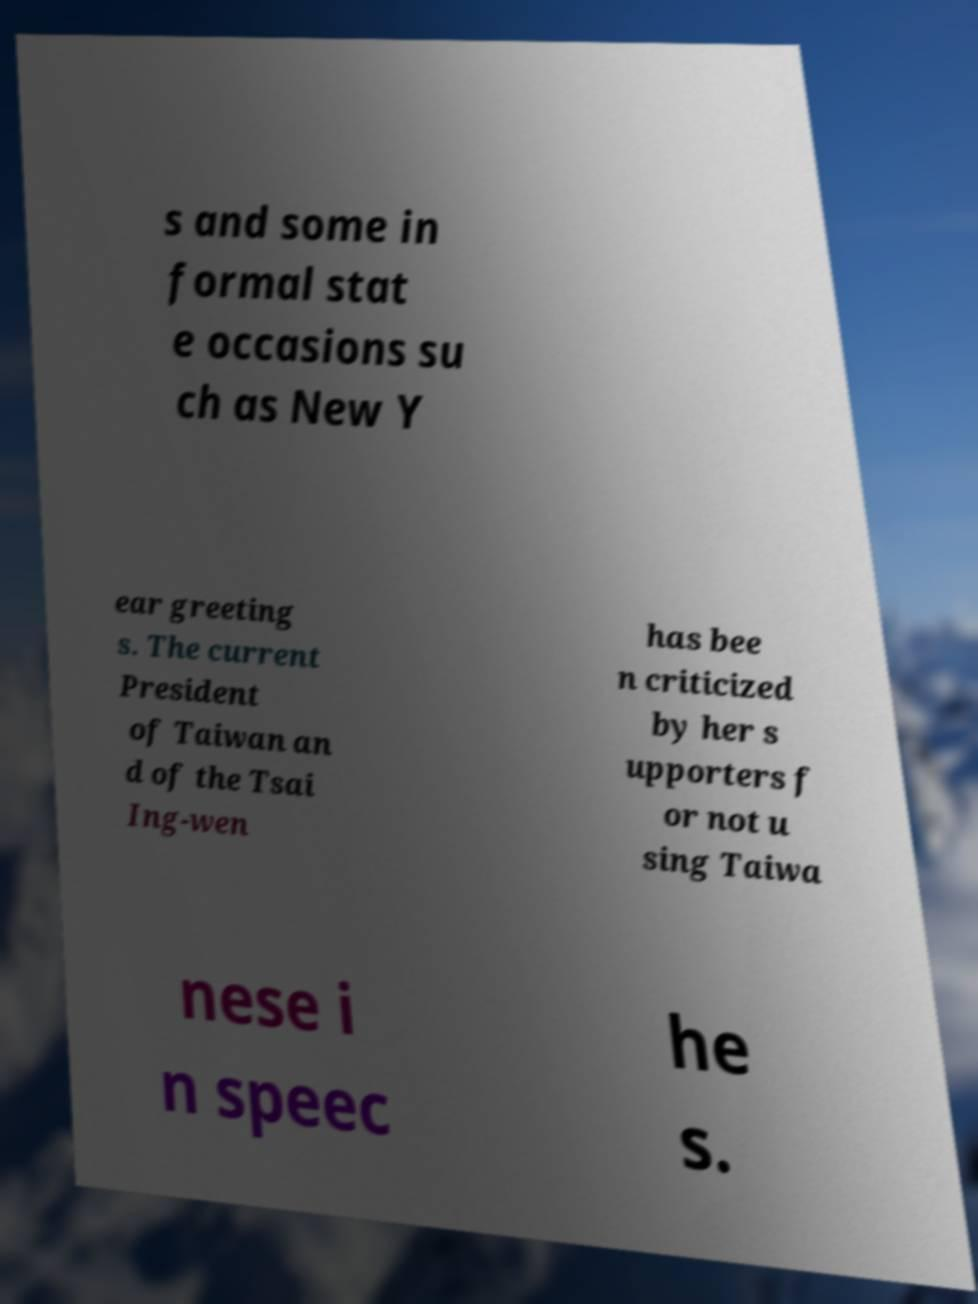I need the written content from this picture converted into text. Can you do that? s and some in formal stat e occasions su ch as New Y ear greeting s. The current President of Taiwan an d of the Tsai Ing-wen has bee n criticized by her s upporters f or not u sing Taiwa nese i n speec he s. 